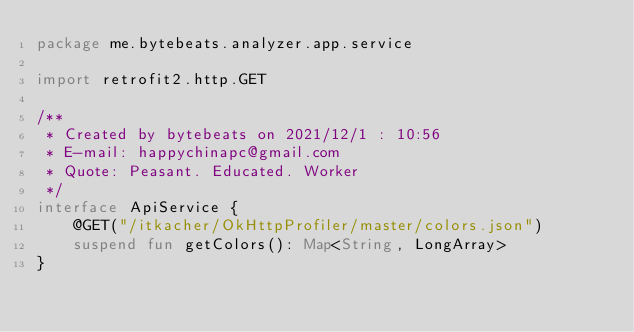<code> <loc_0><loc_0><loc_500><loc_500><_Kotlin_>package me.bytebeats.analyzer.app.service

import retrofit2.http.GET

/**
 * Created by bytebeats on 2021/12/1 : 10:56
 * E-mail: happychinapc@gmail.com
 * Quote: Peasant. Educated. Worker
 */
interface ApiService {
    @GET("/itkacher/OkHttpProfiler/master/colors.json")
    suspend fun getColors(): Map<String, LongArray>
}</code> 